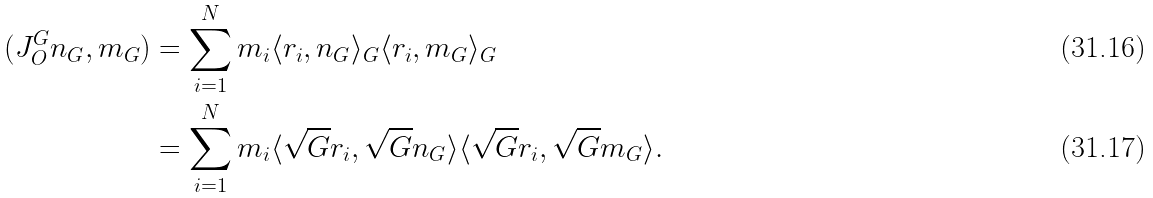<formula> <loc_0><loc_0><loc_500><loc_500>( J ^ { G } _ { O } n _ { G } , m _ { G } ) & = \sum _ { i = 1 } ^ { N } m _ { i } \langle r _ { i } , n _ { G } \rangle _ { G } \langle r _ { i } , m _ { G } \rangle _ { G } \\ & = \sum _ { i = 1 } ^ { N } m _ { i } \langle \sqrt { G } r _ { i } , \sqrt { G } n _ { G } \rangle \langle \sqrt { G } r _ { i } , \sqrt { G } m _ { G } \rangle .</formula> 